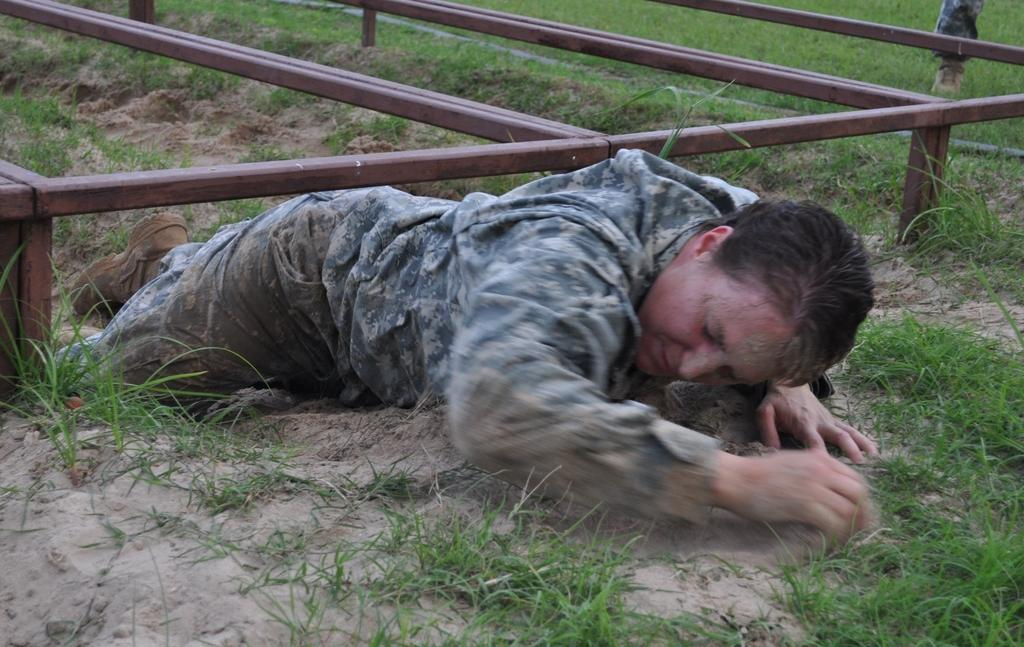What can be seen in the image? There is a person in the image. What is the person wearing? The person is wearing a uniform. What type of terrain is visible at the bottom of the image? There is grass at the bottom of the image. What other type of terrain can be seen in the image? There is sand visible in the image. What objects can be seen in the background of the image? There are rods in the background of the image. Can you tell me how many corn plants are growing in the image? There is no corn visible in the image. Is the person in the image jumping over the rods in the background? The image does not show the person jumping or interacting with the rods in any way. 